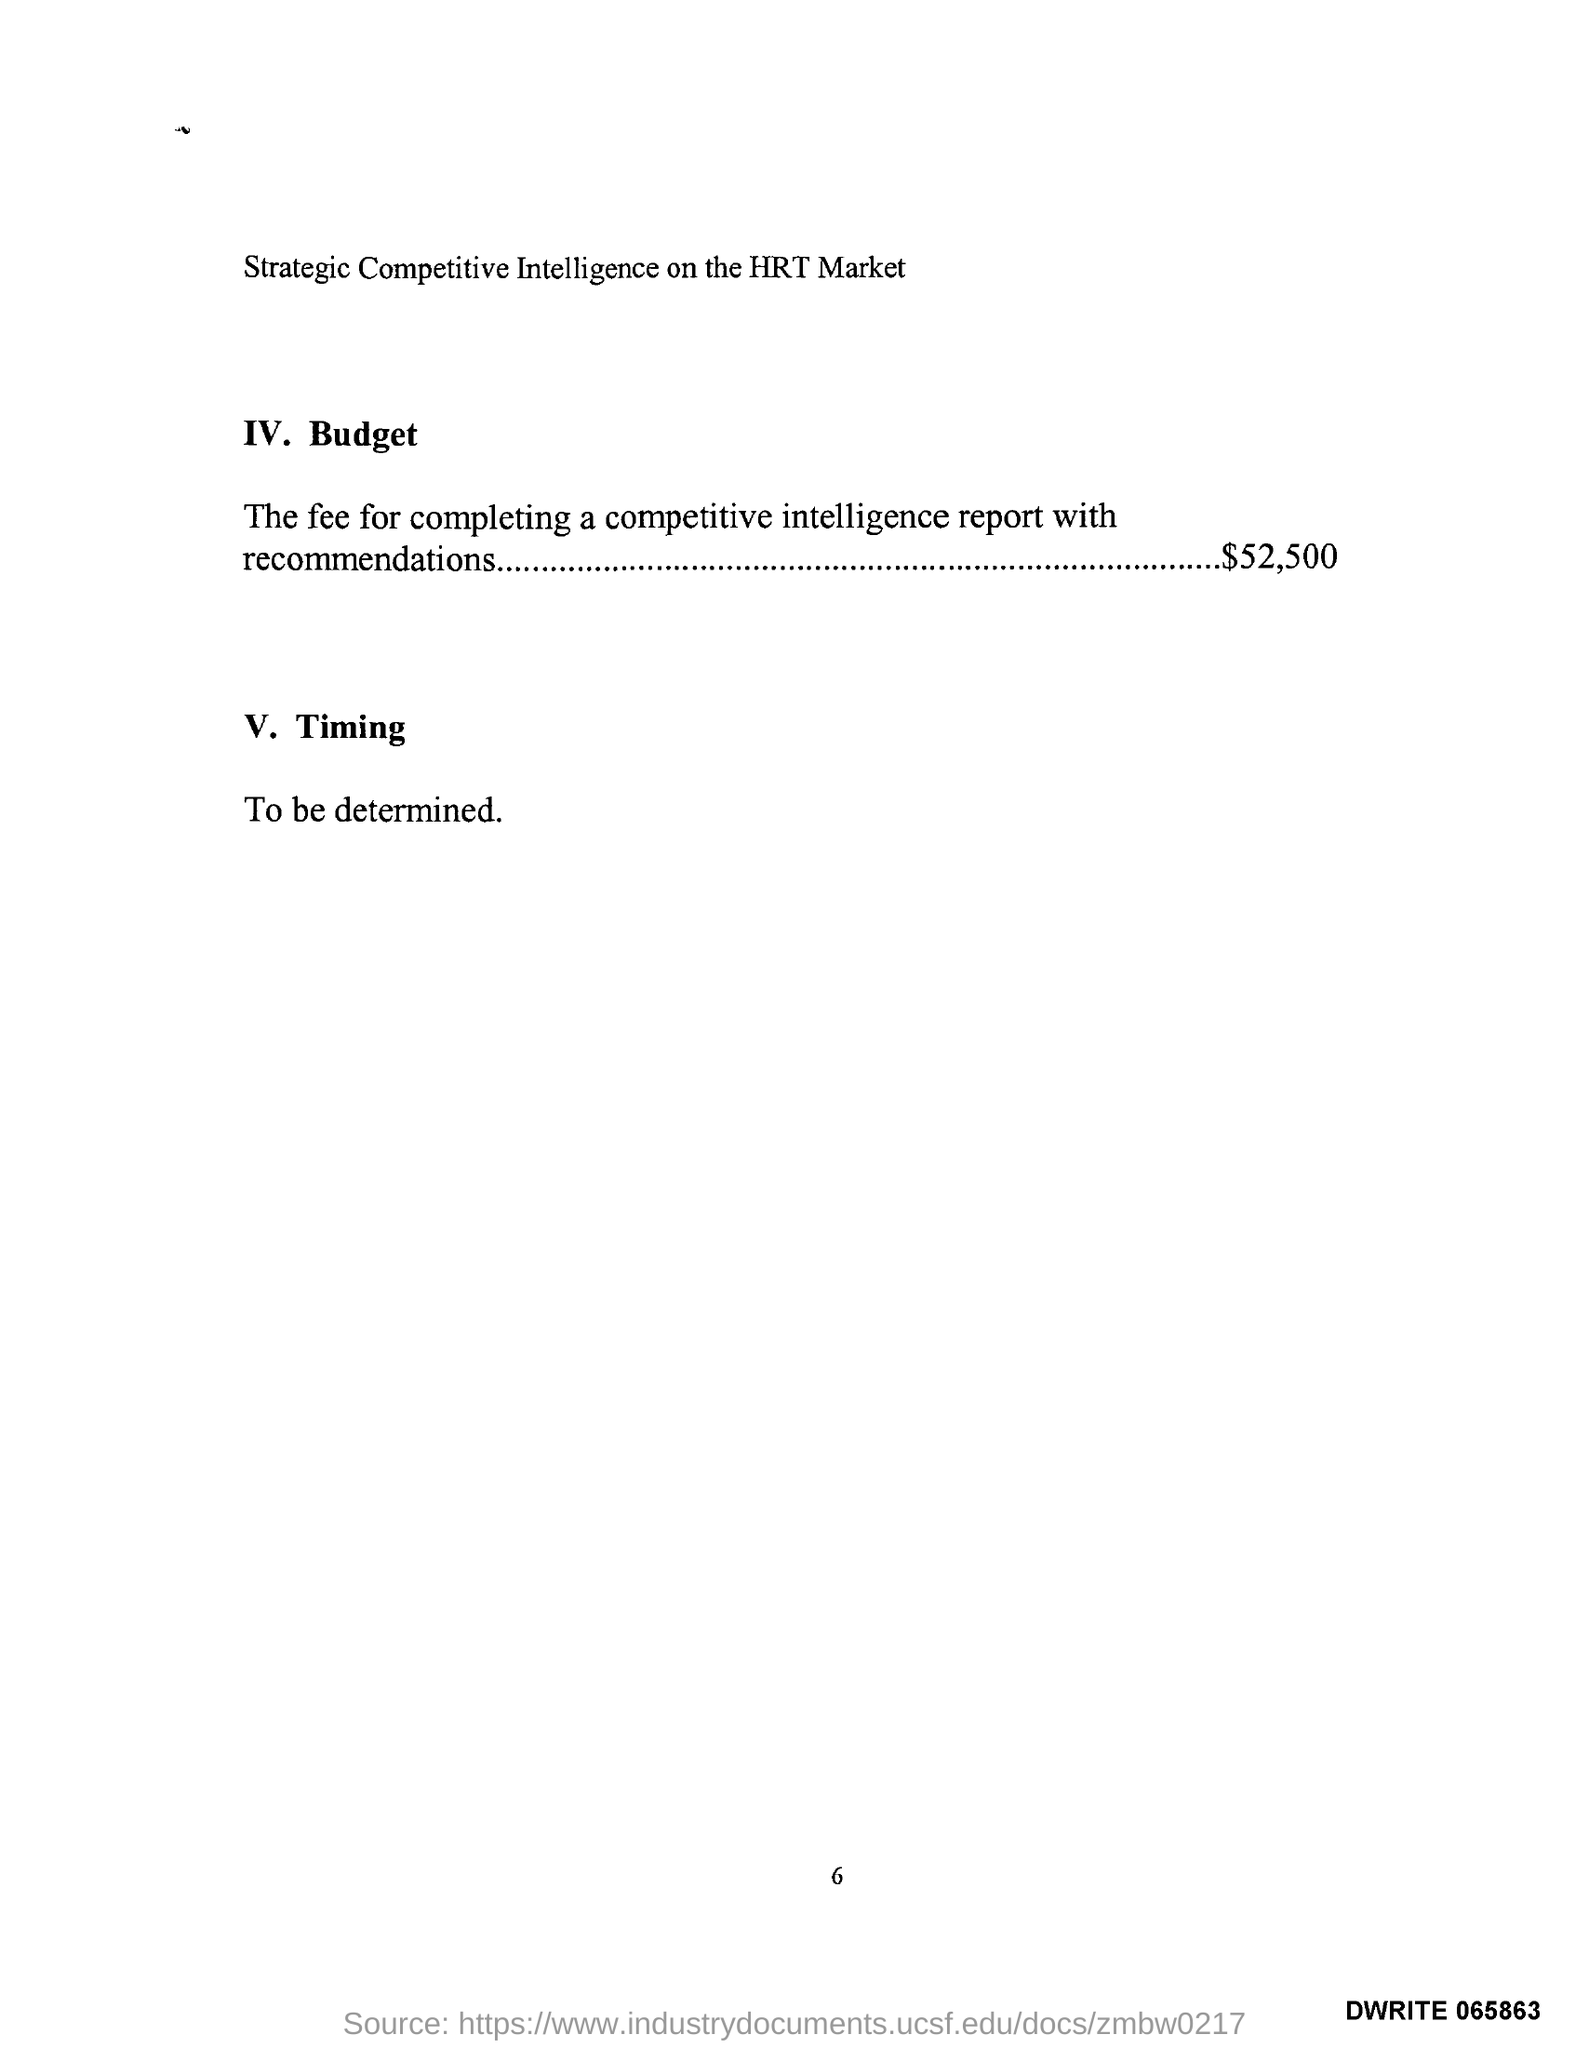What is the description about timing?
Ensure brevity in your answer.  To be determined. What is the budget amount?
Ensure brevity in your answer.  $ 52,500. 